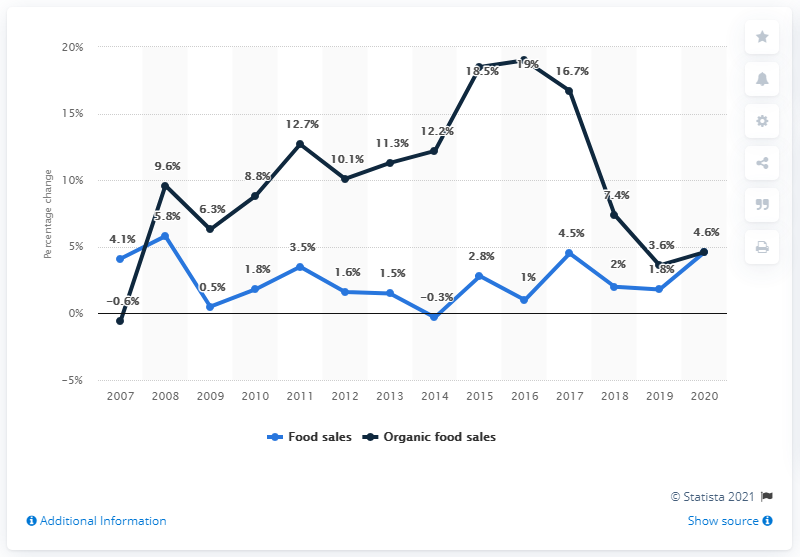Identify some key points in this picture. Organic food sales increased by 4.6% from 2007 to 2020. 